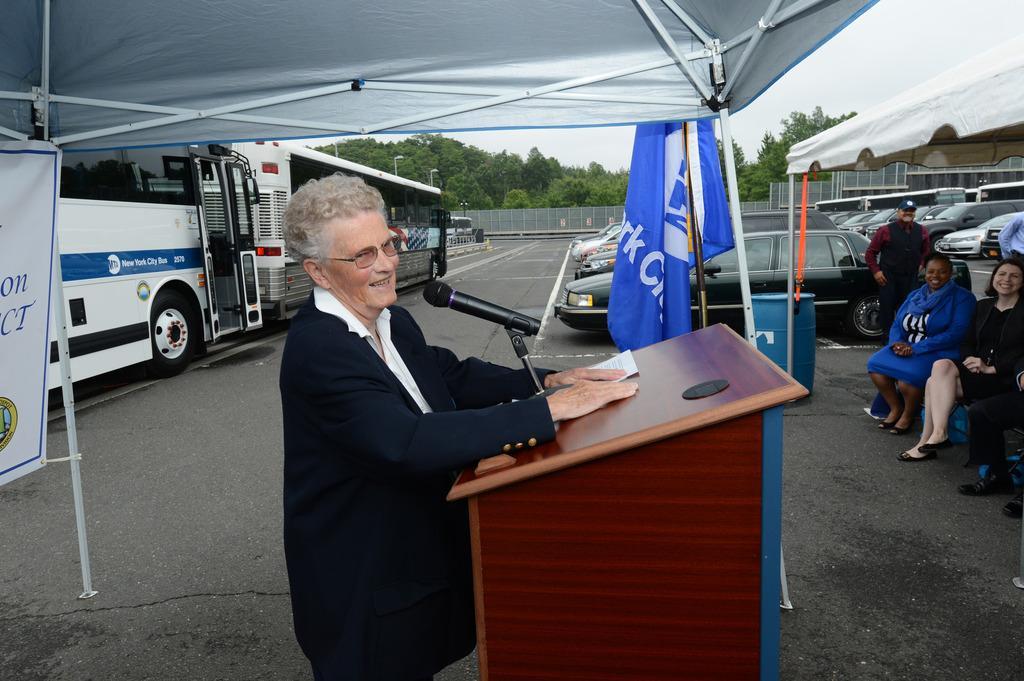How would you summarize this image in a sentence or two? On the right we can see people sitting. At the top it is canopy. In the foreground we can see a woman standing near a podium and talking into a microphone. On the left there are buses. In the middle of the picture there are cars parked in a parking lot. In the center of the background there are trees, fencing, vehicle, road and sky. At the top towards right we can see a canopy and sky. On the left there is a banner also. 